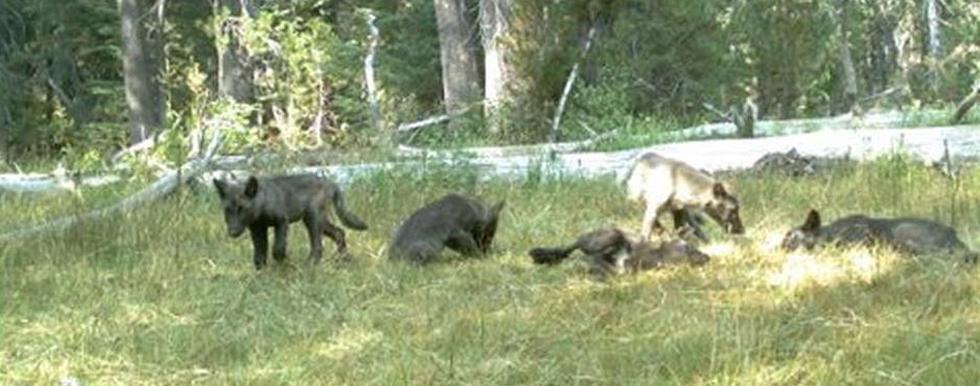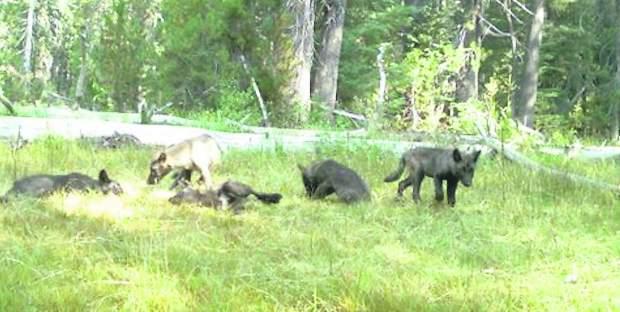The first image is the image on the left, the second image is the image on the right. Assess this claim about the two images: "At least three animals are lying down in the grass in the image on the left.". Correct or not? Answer yes or no. Yes. 